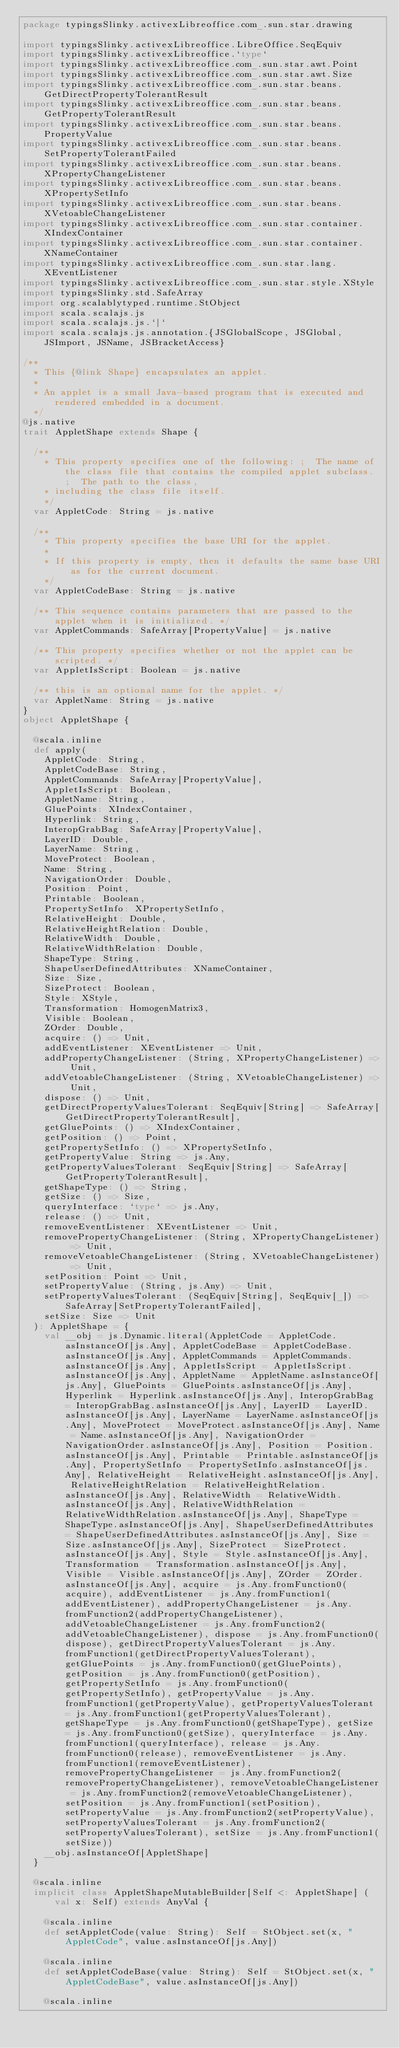<code> <loc_0><loc_0><loc_500><loc_500><_Scala_>package typingsSlinky.activexLibreoffice.com_.sun.star.drawing

import typingsSlinky.activexLibreoffice.LibreOffice.SeqEquiv
import typingsSlinky.activexLibreoffice.`type`
import typingsSlinky.activexLibreoffice.com_.sun.star.awt.Point
import typingsSlinky.activexLibreoffice.com_.sun.star.awt.Size
import typingsSlinky.activexLibreoffice.com_.sun.star.beans.GetDirectPropertyTolerantResult
import typingsSlinky.activexLibreoffice.com_.sun.star.beans.GetPropertyTolerantResult
import typingsSlinky.activexLibreoffice.com_.sun.star.beans.PropertyValue
import typingsSlinky.activexLibreoffice.com_.sun.star.beans.SetPropertyTolerantFailed
import typingsSlinky.activexLibreoffice.com_.sun.star.beans.XPropertyChangeListener
import typingsSlinky.activexLibreoffice.com_.sun.star.beans.XPropertySetInfo
import typingsSlinky.activexLibreoffice.com_.sun.star.beans.XVetoableChangeListener
import typingsSlinky.activexLibreoffice.com_.sun.star.container.XIndexContainer
import typingsSlinky.activexLibreoffice.com_.sun.star.container.XNameContainer
import typingsSlinky.activexLibreoffice.com_.sun.star.lang.XEventListener
import typingsSlinky.activexLibreoffice.com_.sun.star.style.XStyle
import typingsSlinky.std.SafeArray
import org.scalablytyped.runtime.StObject
import scala.scalajs.js
import scala.scalajs.js.`|`
import scala.scalajs.js.annotation.{JSGlobalScope, JSGlobal, JSImport, JSName, JSBracketAccess}

/**
  * This {@link Shape} encapsulates an applet.
  *
  * An applet is a small Java-based program that is executed and rendered embedded in a document.
  */
@js.native
trait AppletShape extends Shape {
  
  /**
    * This property specifies one of the following: ;  The name of the class file that contains the compiled applet subclass. ;  The path to the class,
    * including the class file itself.
    */
  var AppletCode: String = js.native
  
  /**
    * This property specifies the base URI for the applet.
    *
    * If this property is empty, then it defaults the same base URI as for the current document.
    */
  var AppletCodeBase: String = js.native
  
  /** This sequence contains parameters that are passed to the applet when it is initialized. */
  var AppletCommands: SafeArray[PropertyValue] = js.native
  
  /** This property specifies whether or not the applet can be scripted. */
  var AppletIsScript: Boolean = js.native
  
  /** this is an optional name for the applet. */
  var AppletName: String = js.native
}
object AppletShape {
  
  @scala.inline
  def apply(
    AppletCode: String,
    AppletCodeBase: String,
    AppletCommands: SafeArray[PropertyValue],
    AppletIsScript: Boolean,
    AppletName: String,
    GluePoints: XIndexContainer,
    Hyperlink: String,
    InteropGrabBag: SafeArray[PropertyValue],
    LayerID: Double,
    LayerName: String,
    MoveProtect: Boolean,
    Name: String,
    NavigationOrder: Double,
    Position: Point,
    Printable: Boolean,
    PropertySetInfo: XPropertySetInfo,
    RelativeHeight: Double,
    RelativeHeightRelation: Double,
    RelativeWidth: Double,
    RelativeWidthRelation: Double,
    ShapeType: String,
    ShapeUserDefinedAttributes: XNameContainer,
    Size: Size,
    SizeProtect: Boolean,
    Style: XStyle,
    Transformation: HomogenMatrix3,
    Visible: Boolean,
    ZOrder: Double,
    acquire: () => Unit,
    addEventListener: XEventListener => Unit,
    addPropertyChangeListener: (String, XPropertyChangeListener) => Unit,
    addVetoableChangeListener: (String, XVetoableChangeListener) => Unit,
    dispose: () => Unit,
    getDirectPropertyValuesTolerant: SeqEquiv[String] => SafeArray[GetDirectPropertyTolerantResult],
    getGluePoints: () => XIndexContainer,
    getPosition: () => Point,
    getPropertySetInfo: () => XPropertySetInfo,
    getPropertyValue: String => js.Any,
    getPropertyValuesTolerant: SeqEquiv[String] => SafeArray[GetPropertyTolerantResult],
    getShapeType: () => String,
    getSize: () => Size,
    queryInterface: `type` => js.Any,
    release: () => Unit,
    removeEventListener: XEventListener => Unit,
    removePropertyChangeListener: (String, XPropertyChangeListener) => Unit,
    removeVetoableChangeListener: (String, XVetoableChangeListener) => Unit,
    setPosition: Point => Unit,
    setPropertyValue: (String, js.Any) => Unit,
    setPropertyValuesTolerant: (SeqEquiv[String], SeqEquiv[_]) => SafeArray[SetPropertyTolerantFailed],
    setSize: Size => Unit
  ): AppletShape = {
    val __obj = js.Dynamic.literal(AppletCode = AppletCode.asInstanceOf[js.Any], AppletCodeBase = AppletCodeBase.asInstanceOf[js.Any], AppletCommands = AppletCommands.asInstanceOf[js.Any], AppletIsScript = AppletIsScript.asInstanceOf[js.Any], AppletName = AppletName.asInstanceOf[js.Any], GluePoints = GluePoints.asInstanceOf[js.Any], Hyperlink = Hyperlink.asInstanceOf[js.Any], InteropGrabBag = InteropGrabBag.asInstanceOf[js.Any], LayerID = LayerID.asInstanceOf[js.Any], LayerName = LayerName.asInstanceOf[js.Any], MoveProtect = MoveProtect.asInstanceOf[js.Any], Name = Name.asInstanceOf[js.Any], NavigationOrder = NavigationOrder.asInstanceOf[js.Any], Position = Position.asInstanceOf[js.Any], Printable = Printable.asInstanceOf[js.Any], PropertySetInfo = PropertySetInfo.asInstanceOf[js.Any], RelativeHeight = RelativeHeight.asInstanceOf[js.Any], RelativeHeightRelation = RelativeHeightRelation.asInstanceOf[js.Any], RelativeWidth = RelativeWidth.asInstanceOf[js.Any], RelativeWidthRelation = RelativeWidthRelation.asInstanceOf[js.Any], ShapeType = ShapeType.asInstanceOf[js.Any], ShapeUserDefinedAttributes = ShapeUserDefinedAttributes.asInstanceOf[js.Any], Size = Size.asInstanceOf[js.Any], SizeProtect = SizeProtect.asInstanceOf[js.Any], Style = Style.asInstanceOf[js.Any], Transformation = Transformation.asInstanceOf[js.Any], Visible = Visible.asInstanceOf[js.Any], ZOrder = ZOrder.asInstanceOf[js.Any], acquire = js.Any.fromFunction0(acquire), addEventListener = js.Any.fromFunction1(addEventListener), addPropertyChangeListener = js.Any.fromFunction2(addPropertyChangeListener), addVetoableChangeListener = js.Any.fromFunction2(addVetoableChangeListener), dispose = js.Any.fromFunction0(dispose), getDirectPropertyValuesTolerant = js.Any.fromFunction1(getDirectPropertyValuesTolerant), getGluePoints = js.Any.fromFunction0(getGluePoints), getPosition = js.Any.fromFunction0(getPosition), getPropertySetInfo = js.Any.fromFunction0(getPropertySetInfo), getPropertyValue = js.Any.fromFunction1(getPropertyValue), getPropertyValuesTolerant = js.Any.fromFunction1(getPropertyValuesTolerant), getShapeType = js.Any.fromFunction0(getShapeType), getSize = js.Any.fromFunction0(getSize), queryInterface = js.Any.fromFunction1(queryInterface), release = js.Any.fromFunction0(release), removeEventListener = js.Any.fromFunction1(removeEventListener), removePropertyChangeListener = js.Any.fromFunction2(removePropertyChangeListener), removeVetoableChangeListener = js.Any.fromFunction2(removeVetoableChangeListener), setPosition = js.Any.fromFunction1(setPosition), setPropertyValue = js.Any.fromFunction2(setPropertyValue), setPropertyValuesTolerant = js.Any.fromFunction2(setPropertyValuesTolerant), setSize = js.Any.fromFunction1(setSize))
    __obj.asInstanceOf[AppletShape]
  }
  
  @scala.inline
  implicit class AppletShapeMutableBuilder[Self <: AppletShape] (val x: Self) extends AnyVal {
    
    @scala.inline
    def setAppletCode(value: String): Self = StObject.set(x, "AppletCode", value.asInstanceOf[js.Any])
    
    @scala.inline
    def setAppletCodeBase(value: String): Self = StObject.set(x, "AppletCodeBase", value.asInstanceOf[js.Any])
    
    @scala.inline</code> 